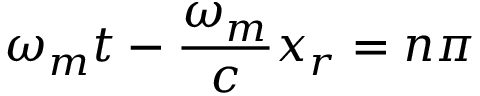Convert formula to latex. <formula><loc_0><loc_0><loc_500><loc_500>\omega _ { m } t - \frac { \omega _ { m } } { c } x _ { r } = n \pi</formula> 